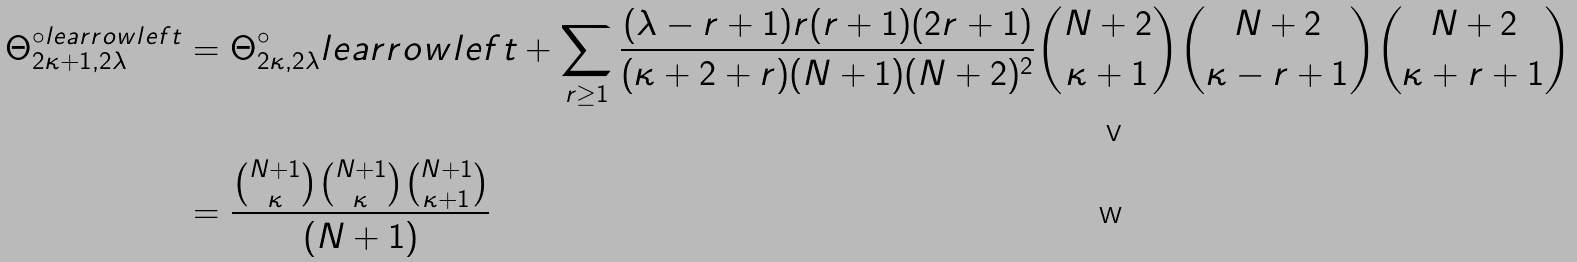<formula> <loc_0><loc_0><loc_500><loc_500>\Theta _ { 2 \kappa + 1 , 2 \lambda } ^ { \circ l e a r r o w l e f t } & = \Theta _ { 2 \kappa , 2 \lambda } ^ { \circ } l e a r r o w l e f t + \sum _ { r \geq 1 } \frac { ( \lambda - r + 1 ) r ( r + 1 ) ( 2 r + 1 ) } { ( \kappa + 2 + r ) ( N + 1 ) ( N + 2 ) ^ { 2 } } \binom { N + 2 } { \kappa + 1 } \binom { N + 2 } { \kappa - r + 1 } \binom { N + 2 } { \kappa + r + 1 } & \\ & = \frac { \binom { N + 1 } { \kappa } \binom { N + 1 } { \kappa } \binom { N + 1 } { \kappa + 1 } } { ( N + 1 ) }</formula> 